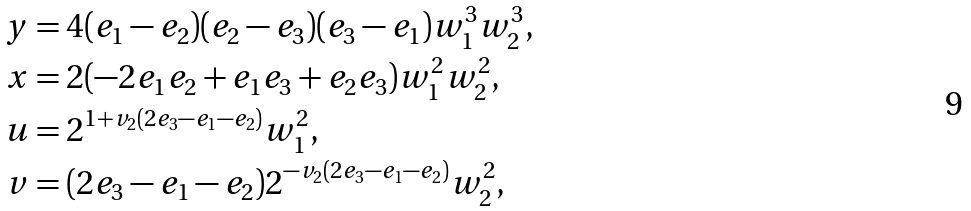Convert formula to latex. <formula><loc_0><loc_0><loc_500><loc_500>y & = 4 ( e _ { 1 } - e _ { 2 } ) ( e _ { 2 } - e _ { 3 } ) ( e _ { 3 } - e _ { 1 } ) w _ { 1 } ^ { 3 } w _ { 2 } ^ { 3 } , \\ x & = 2 ( - 2 e _ { 1 } e _ { 2 } + e _ { 1 } e _ { 3 } + e _ { 2 } e _ { 3 } ) w _ { 1 } ^ { 2 } w _ { 2 } ^ { 2 } , \\ u & = 2 ^ { 1 + v _ { 2 } ( 2 e _ { 3 } - e _ { 1 } - e _ { 2 } ) } w _ { 1 } ^ { 2 } , \\ v & = ( 2 e _ { 3 } - e _ { 1 } - e _ { 2 } ) 2 ^ { - v _ { 2 } ( 2 e _ { 3 } - e _ { 1 } - e _ { 2 } ) } w _ { 2 } ^ { 2 } ,</formula> 